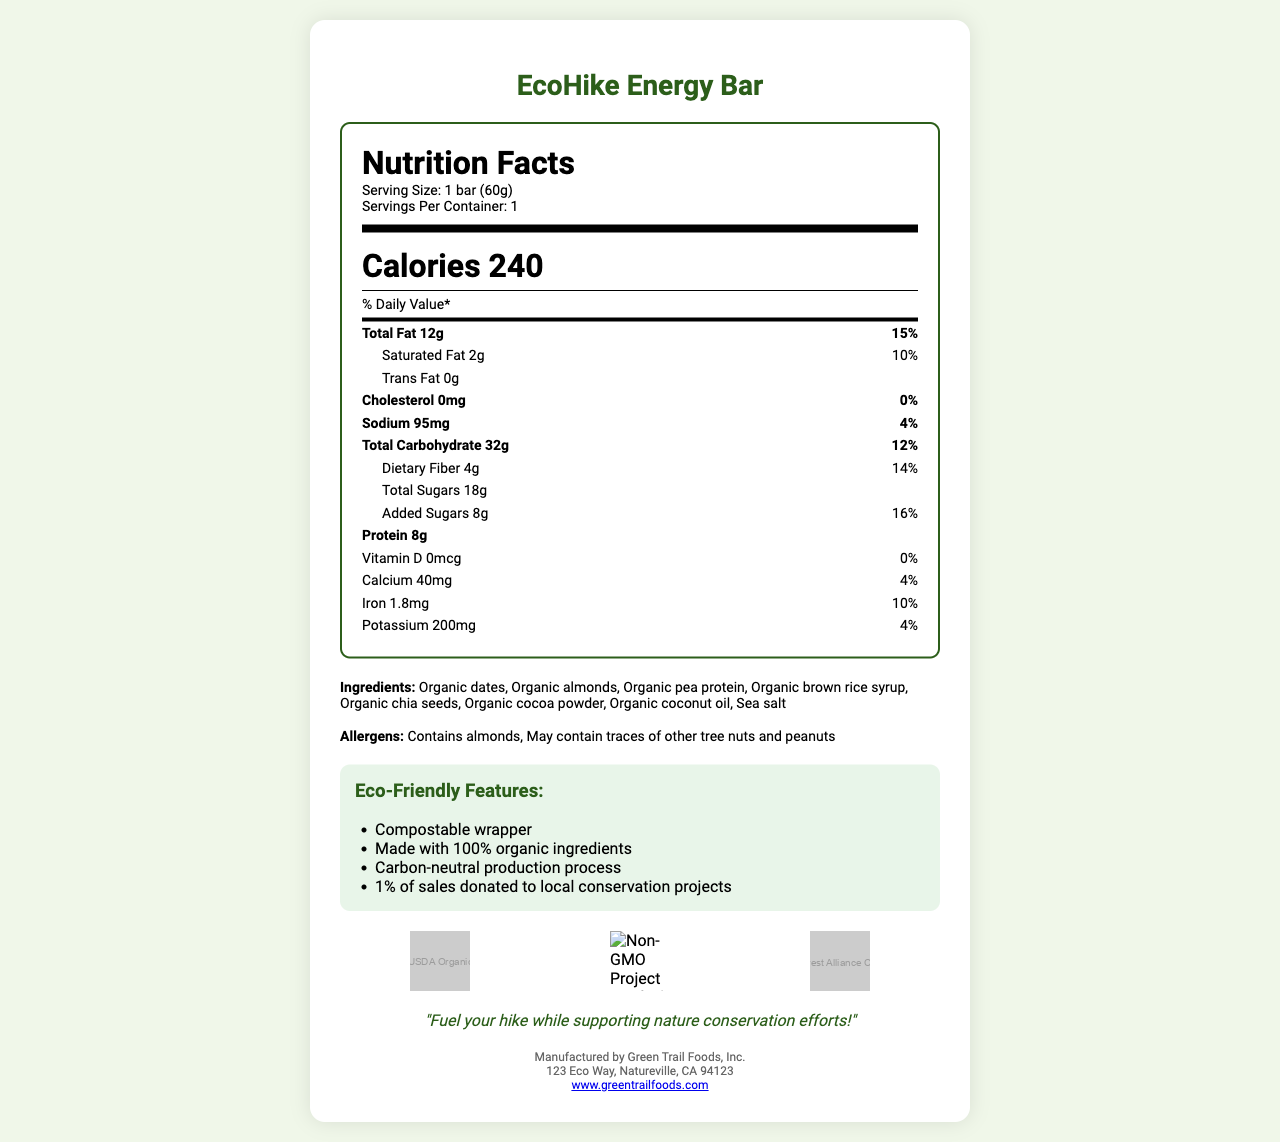what is the serving size of the EcoHike Energy Bar? The serving size is mentioned at the beginning of the nutrition facts section under "Serving Size".
Answer: 1 bar (60g) how many calories are in one serving of the EcoHike Energy Bar? The total calories are listed right below the nutrition facts heading with the bold text "Calories 240".
Answer: 240 how much total fat does one EcoHike Energy Bar contain? The total fat amount is mentioned in the nutrition facts section under "Total Fat" with the amount "12g".
Answer: 12g what is the percent daily value of sodium in the EcoHike Energy Bar? The percent daily value for sodium is listed as "4%" in the sodium section of the nutrition facts label.
Answer: 4% what are the main ingredients in the EcoHike Energy Bar? The ingredients are listed near the bottom of the document under "Ingredients".
Answer: Organic dates, Organic almonds, Organic pea protein, Organic brown rice syrup, Organic chia seeds, Organic cocoa powder, Organic coconut oil, Sea salt which of the following eco-friendly features does the EcoHike Energy Bar have? A. Recyclable wrapper B. Made with organic ingredients C. Carbon-neutral production D. Supports local farmers The eco-friendly features are listed under "Eco-Friendly Features" and include "Made with 100% organic ingredients" and "Carbon-neutral production process".
Answer: B, C what certifications does the EcoHike Energy Bar have? A. USDA Organic B. Gluten-Free Certified C. Non-GMO Project Verified D. Fair Trade Certified The certification logos shown in the document include "USDA Organic" and "Non-GMO Project Verified".
Answer: A, C is the EcoHike Energy Bar suitable for individuals with nut allergies? The allergen information states that the product contains almonds and may contain traces of other tree nuts and peanuts.
Answer: No what is the main idea of the EcoHike Energy Bar document? The document provides comprehensive information about the EcoHike Energy Bar, including its health benefits, sustainability features, and conservation support.
Answer: The document presents the nutrition facts, ingredients, eco-friendly features, certifications, and allergen information for the EcoHike Energy Bar, an eco-friendly snack made with organic ingredients and designed for nature conservation hikes. what is the address of the manufacturer of the EcoHike Energy Bar? The manufacturer’s address is listed at the bottom of the document under "Manufactured by Green Trail Foods, Inc."
Answer: 123 Eco Way, Natureville, CA 94123 how much protein is in the EcoHike Energy Bar? The amount of protein is listed in the nutrition facts section under "Protein" with the amount "8g".
Answer: 8g what is the daily value percentage of added sugars in the EcoHike Energy Bar? The daily value percentage of added sugars is stated as "16%" in the added sugars section of the nutrition facts label.
Answer: 16% how many calories come from fat in the EcoHike Energy Bar? The document does not provide specific information on the number of calories derived from fat.
Answer: Not enough information is the EcoHike Energy Bar cholesterol free? The nutrition facts label shows that the cholesterol amount is "0mg" with a daily value of "0%", indicating it is cholesterol free.
Answer: Yes how much potassium does the EcoHike Energy Bar contain? The potassium amount is listed in the nutrition facts under "Potassium" with the amount "200mg".
Answer: 200mg 